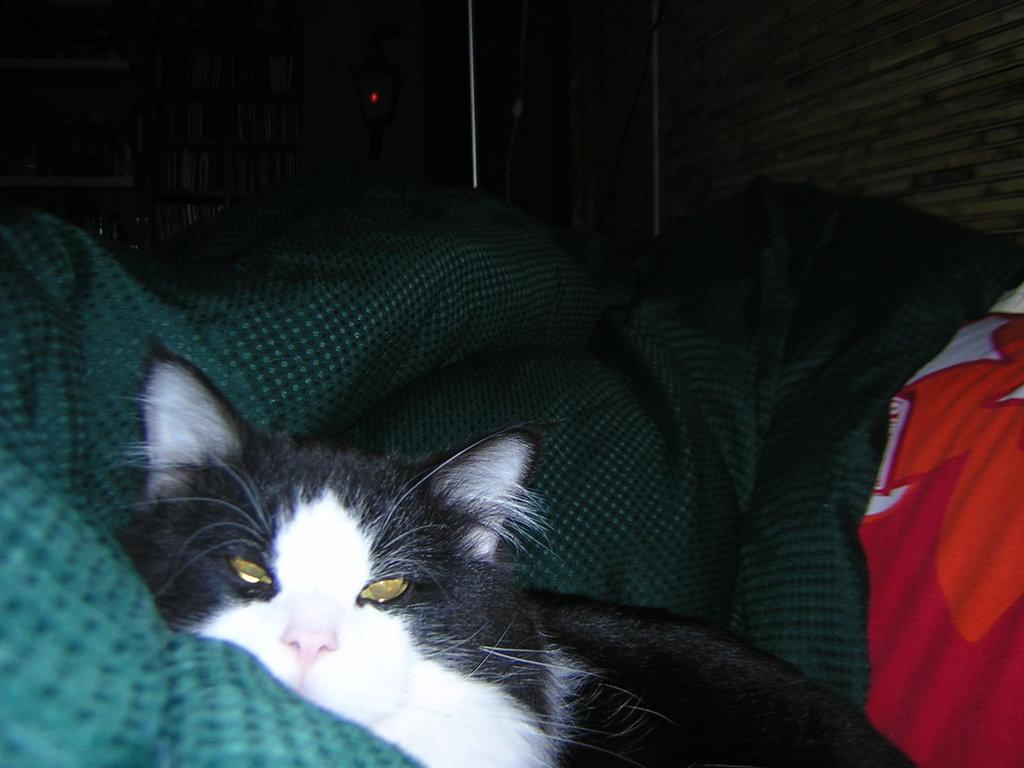What type of animal is in the image? There is a cat in the image. Who or what else is in the image? There is a person in the image. What is covering the bed in the image? There is a bed sheet in the image. What can be seen in the background of the image? There is a wall in the background of the image. What type of class is being taught in the image? There is no class or teaching activity depicted in the image. 